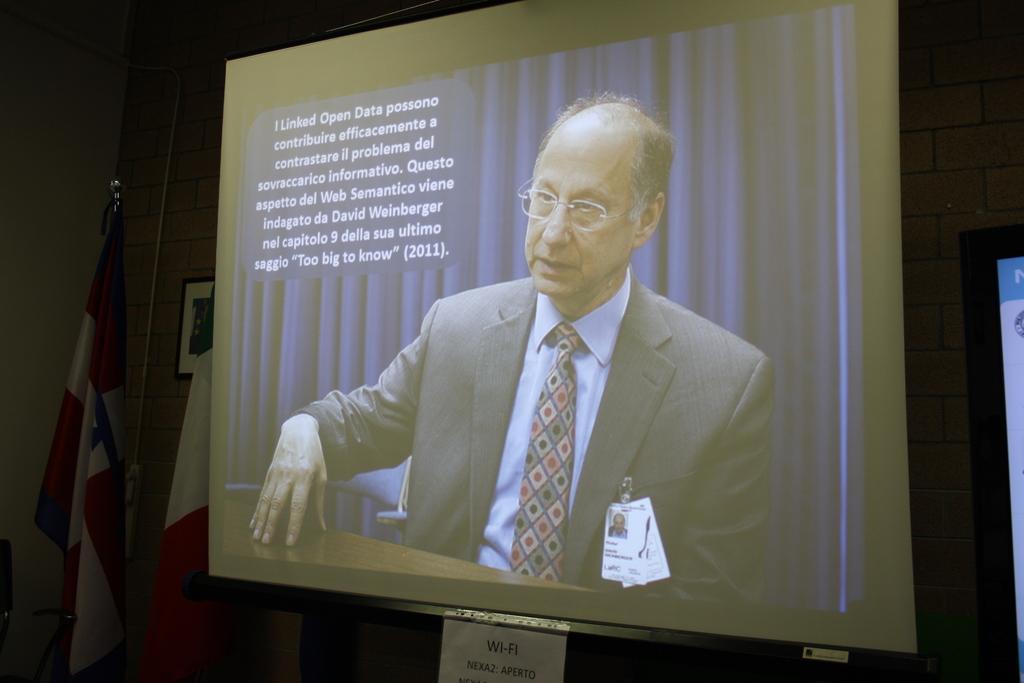Could you give a brief overview of what you see in this image? This picture shows a projector screen and we see a man seated. He wore spectacles on his face and we see id cards to the coat he wore and we see text and we see couple of flags and a photo frame on the wall. 